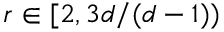<formula> <loc_0><loc_0><loc_500><loc_500>r \in [ 2 , 3 d / ( d - 1 ) )</formula> 